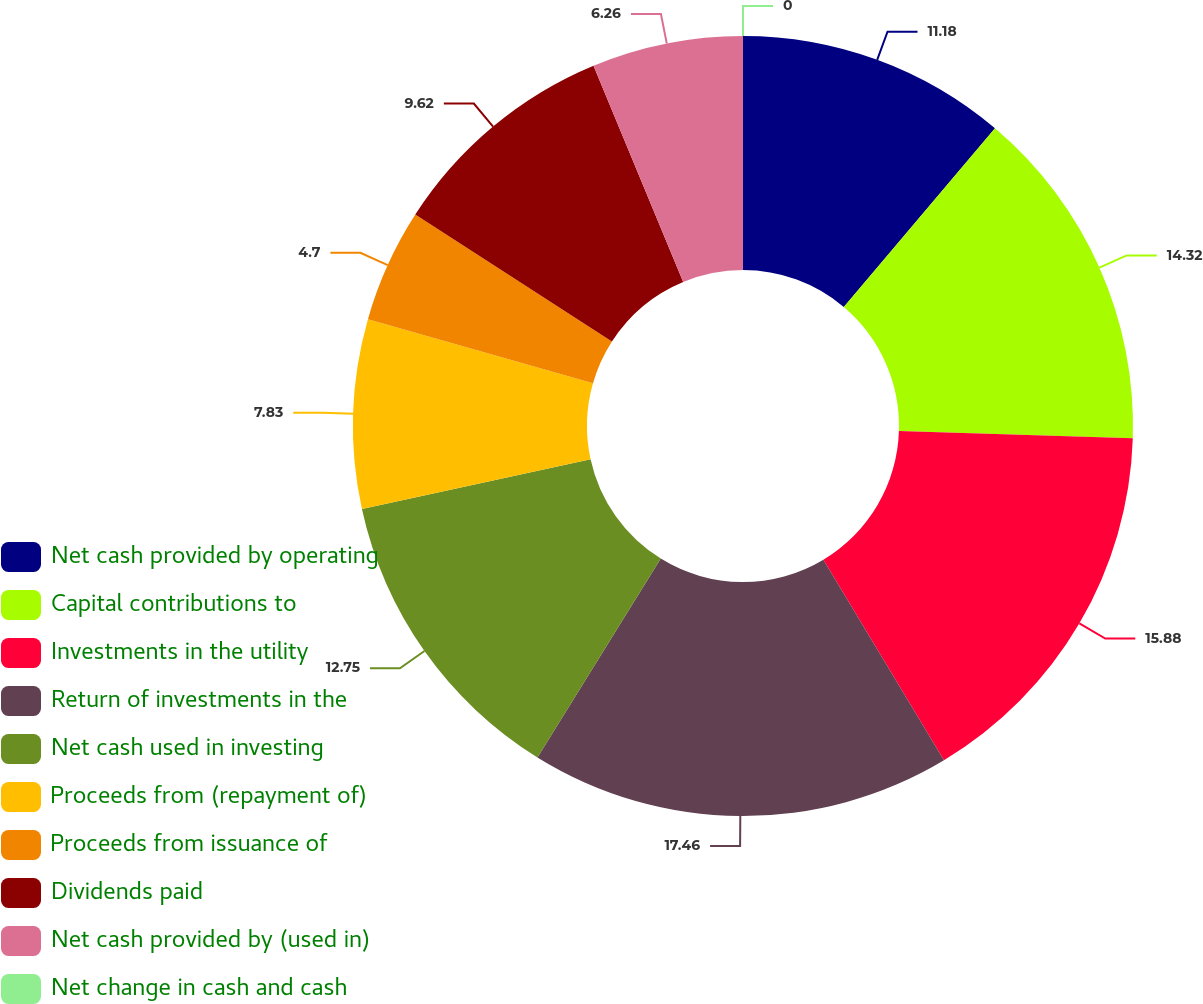<chart> <loc_0><loc_0><loc_500><loc_500><pie_chart><fcel>Net cash provided by operating<fcel>Capital contributions to<fcel>Investments in the utility<fcel>Return of investments in the<fcel>Net cash used in investing<fcel>Proceeds from (repayment of)<fcel>Proceeds from issuance of<fcel>Dividends paid<fcel>Net cash provided by (used in)<fcel>Net change in cash and cash<nl><fcel>11.18%<fcel>14.32%<fcel>15.88%<fcel>17.45%<fcel>12.75%<fcel>7.83%<fcel>4.7%<fcel>9.62%<fcel>6.26%<fcel>0.0%<nl></chart> 